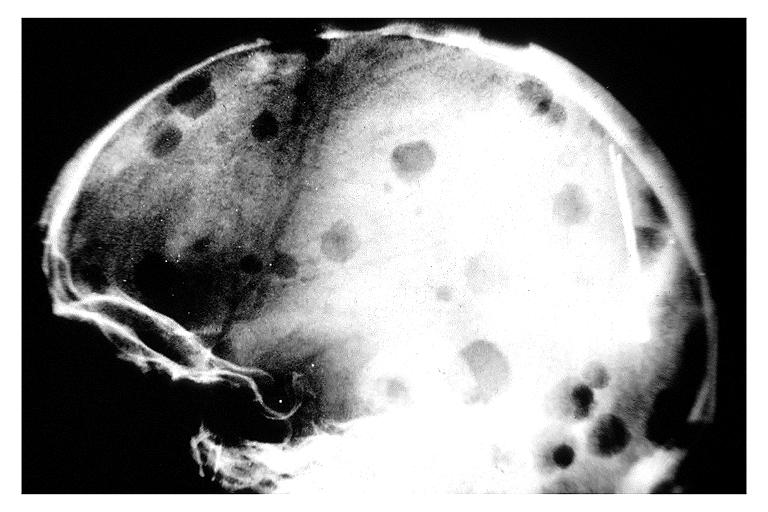what does this image show?
Answer the question using a single word or phrase. Multiple myeloma 